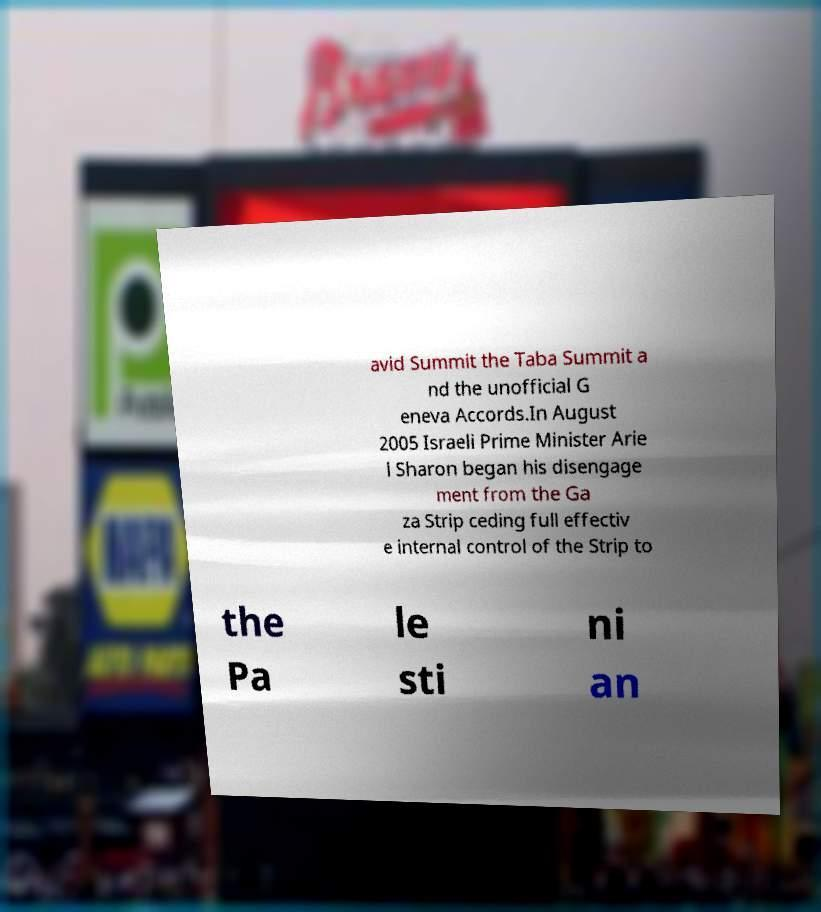For documentation purposes, I need the text within this image transcribed. Could you provide that? avid Summit the Taba Summit a nd the unofficial G eneva Accords.In August 2005 Israeli Prime Minister Arie l Sharon began his disengage ment from the Ga za Strip ceding full effectiv e internal control of the Strip to the Pa le sti ni an 